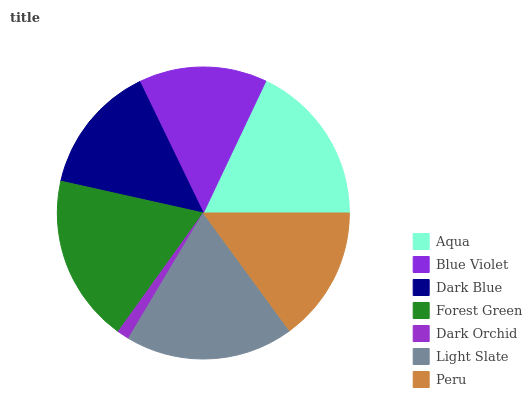Is Dark Orchid the minimum?
Answer yes or no. Yes. Is Light Slate the maximum?
Answer yes or no. Yes. Is Blue Violet the minimum?
Answer yes or no. No. Is Blue Violet the maximum?
Answer yes or no. No. Is Aqua greater than Blue Violet?
Answer yes or no. Yes. Is Blue Violet less than Aqua?
Answer yes or no. Yes. Is Blue Violet greater than Aqua?
Answer yes or no. No. Is Aqua less than Blue Violet?
Answer yes or no. No. Is Peru the high median?
Answer yes or no. Yes. Is Peru the low median?
Answer yes or no. Yes. Is Blue Violet the high median?
Answer yes or no. No. Is Dark Orchid the low median?
Answer yes or no. No. 